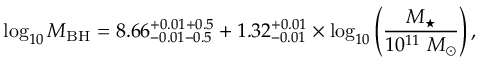<formula> <loc_0><loc_0><loc_500><loc_500>\log _ { 1 0 } M _ { B H } = 8 . 6 6 _ { - 0 . 0 1 - 0 . 5 } ^ { + 0 . 0 1 + 0 . 5 } + 1 . 3 2 _ { - 0 . 0 1 } ^ { + 0 . 0 1 } \times \log _ { 1 0 } \left ( \frac { M _ { ^ { * } } } { 1 0 ^ { 1 1 } \ M _ { \odot } } \right ) ,</formula> 